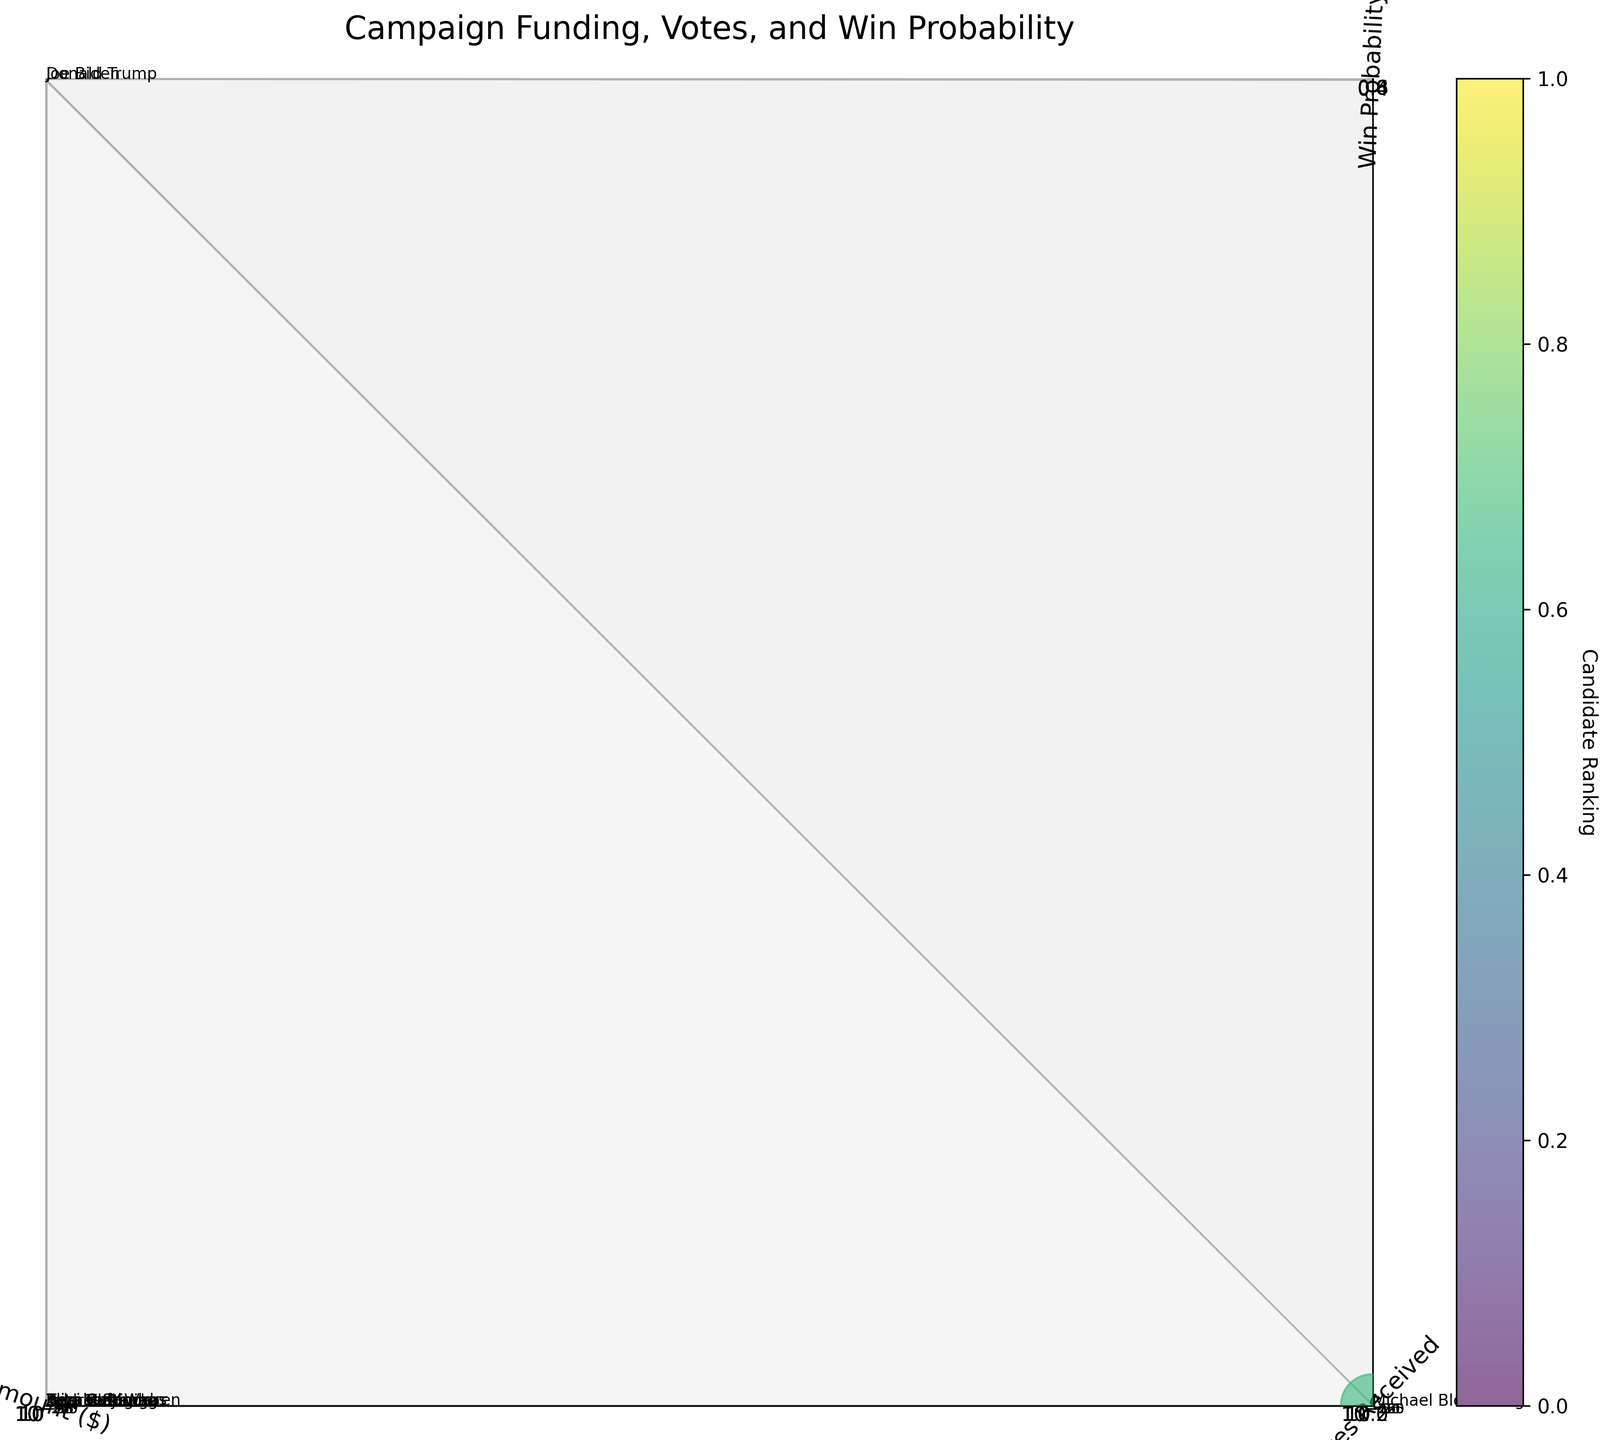How many candidates are represented in the figure? Count the number of unique candidates displayed on the plot. Since each candidate has one bubble, you can count the bubbles or check the list of labels near the bubbles.
Answer: 10 Which candidate received the highest amount of funding? Look at the x-axis (Amount) and identify which bubble is farthest to the right. The label near this bubble indicates the candidate.
Answer: Michael Bloomberg Compare Joe Biden and Donald Trump: who received more votes? Look at the y-axis (Votes Received) for Joe Biden and Donald Trump. Identify which bubble is higher on the y-axis.
Answer: Joe Biden Which candidate has the lowest win probability? Look at the z-axis (Win Probability) and identify the bubble closest to the bottom. The label near this bubble indicates the candidate.
Answer: Tulsi Gabbard What is the relationship between funding amount and votes received for the candidates? Observe the general trend along the x-axis (Amount) and y-axis (Votes Received). Evaluate whether higher funding correlates with higher votes or if there's no clear pattern.
Answer: Mixed relationship Which candidate is represented by the largest bubble? Larger bubbles represent higher amounts of funding. Compare the sizes of the bubbles to determine which one is the largest.
Answer: Michael Bloomberg How does Elizabeth Warren's win probability compare to Bernie Sanders? Look at the z-axis (Win Probability) for Elizabeth Warren and Bernie Sanders. Identify which bubble is higher on the z-axis.
Answer: Lower Who is the candidate funded by PACs and where do they stand in terms of votes received? Identify the candidate funded by PACs from the data provided. Look at their position on the y-axis (Votes Received) to determine the number of votes they received.
Answer: Donald Trump, second-highest Sum the total amount of funding received by the three candidates with the smallest bubbles. Identify the three smallest bubbles, referring to their funding sources and amounts from the data. Sum these amounts: 150,000 + 250,000 + 300,000.
Answer: 700,000 Which candidate has a higher win probability: Pete Buttigieg or Amy Klobuchar? Compare the positions on the z-axis (Win Probability) for Pete Buttigieg and Amy Klobuchar to see which bubble is higher.
Answer: Pete Buttigieg 